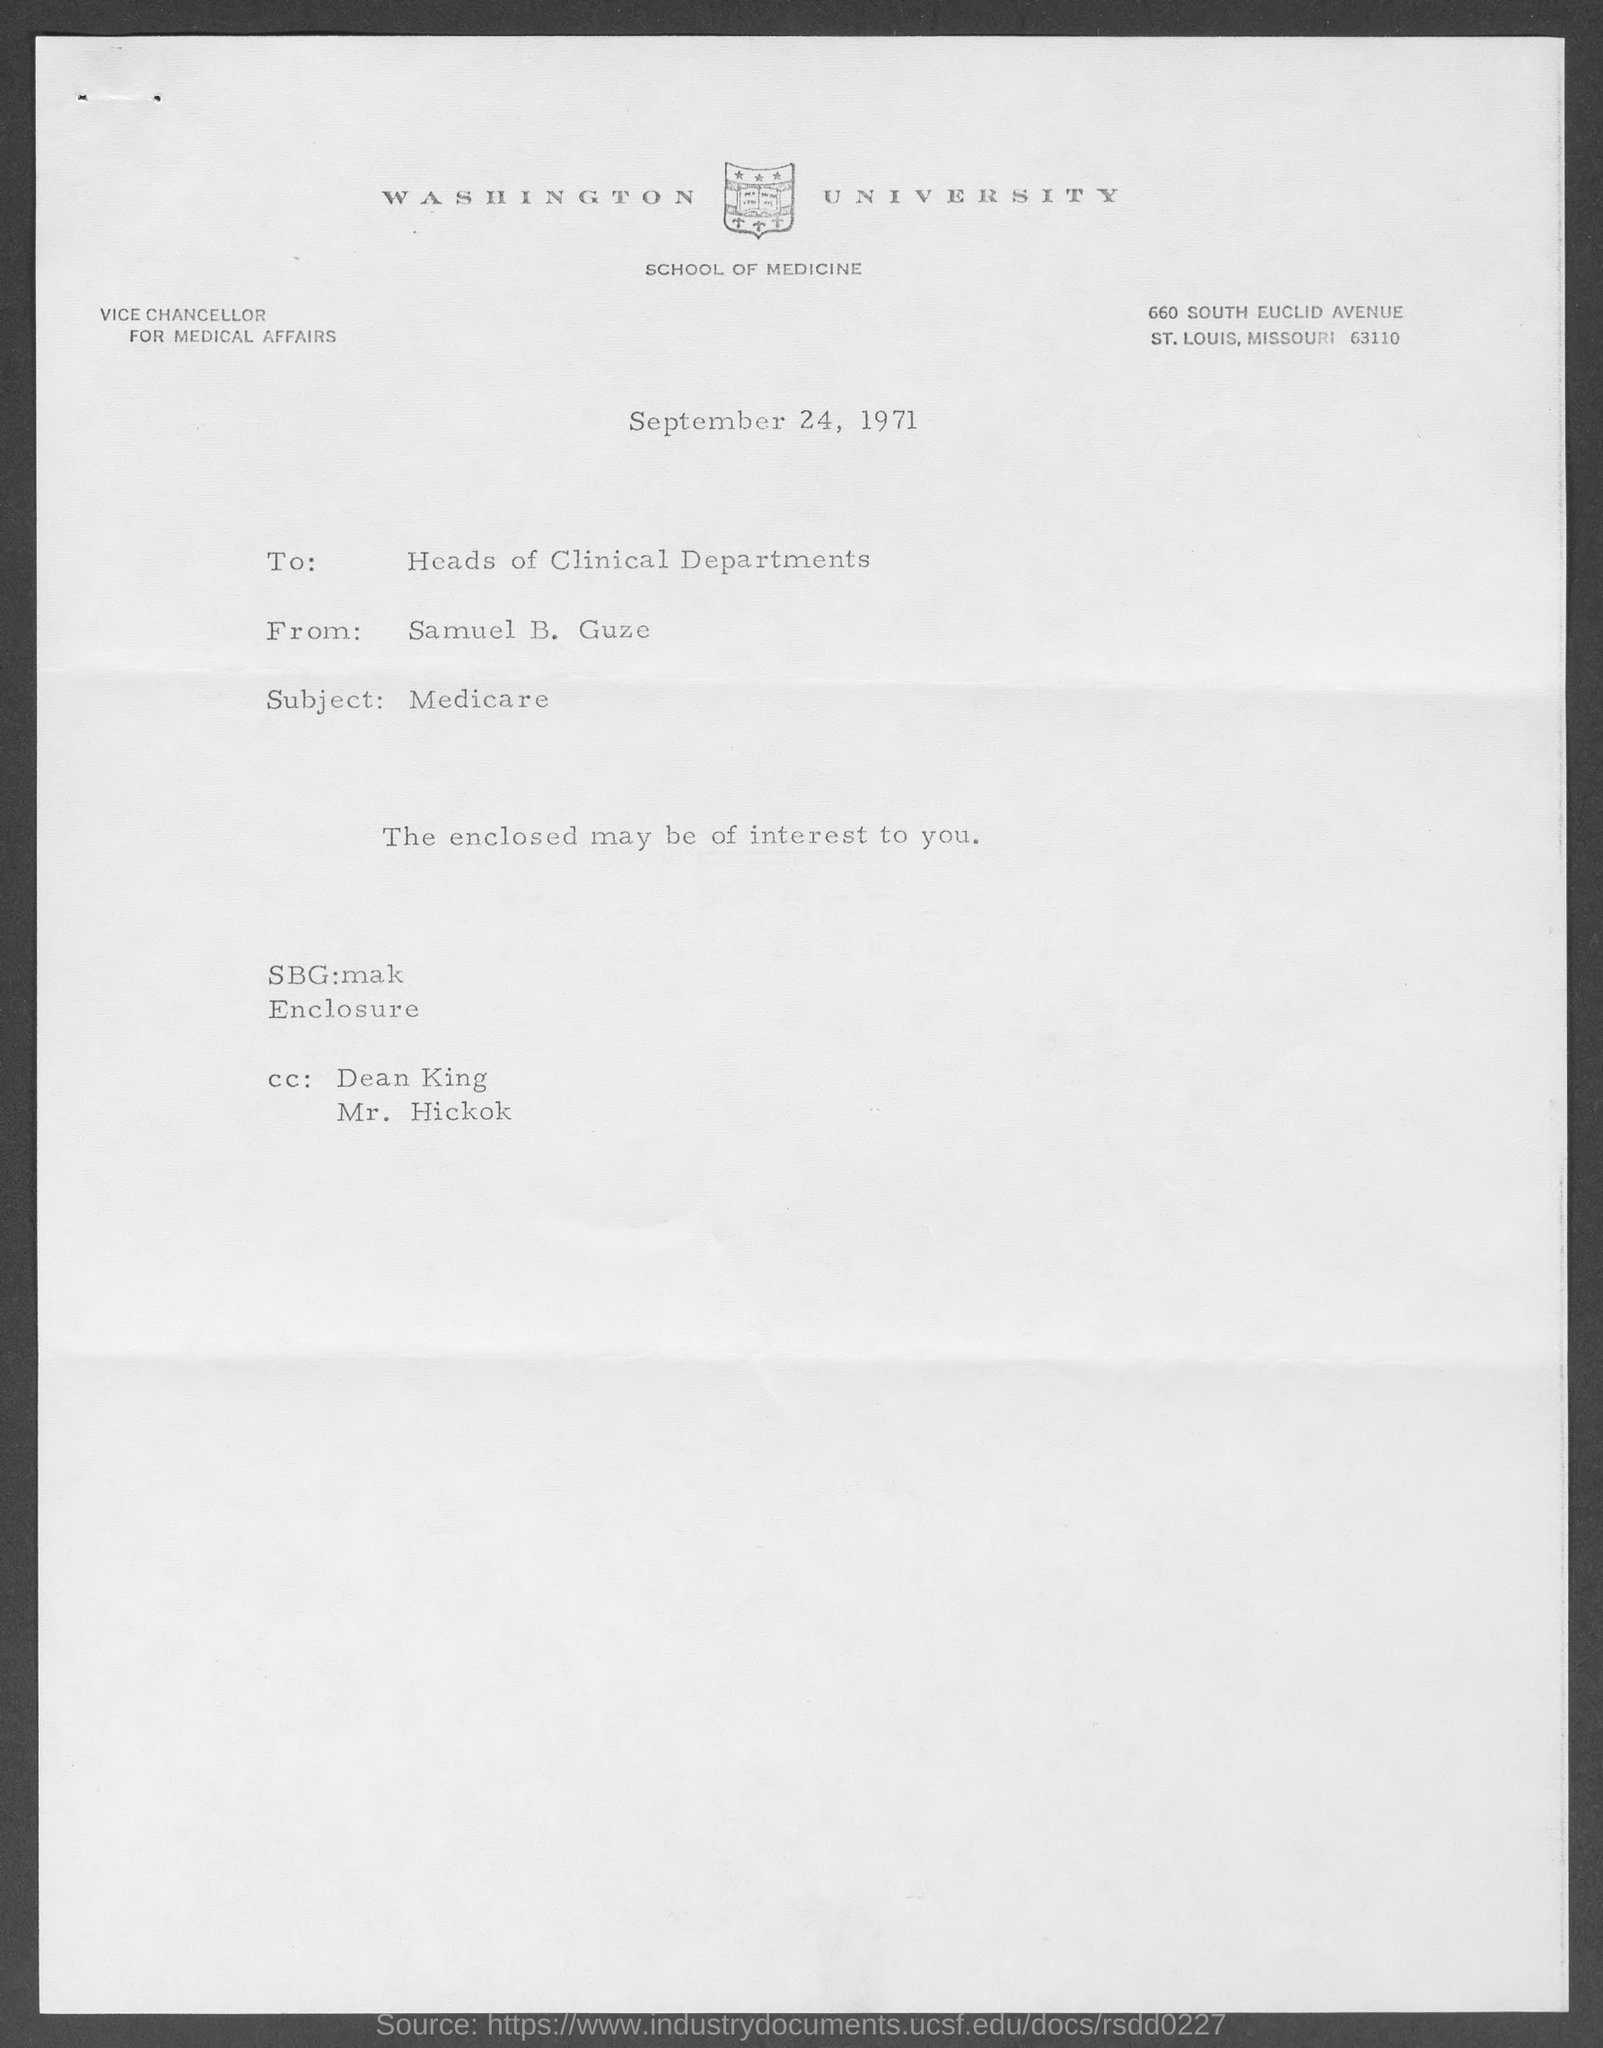Outline some significant characteristics in this image. The letter mentions a date of September 24, 1971. The addressee of this letter is the Heads of Clinical Departments. The letter is from Samuel B. Guze. The letterhead mentions Washington University. The subject of this letter is Medicare. 